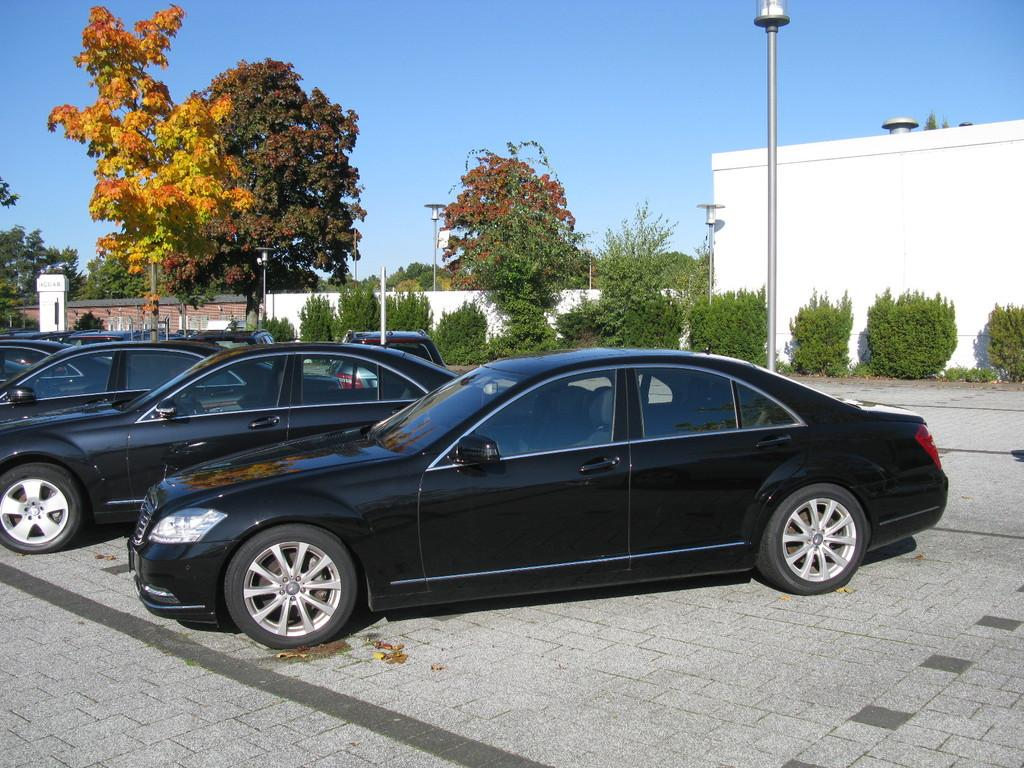What can be seen parked in the image? There are cars parked in the image. What structure is present in the image that provides light? There is a light pole in the image. What type of vegetation is visible in the image? Trees and bushes are present in the image. What type of man-made structure is visible in the image? There is a building wall in the image. What architectural feature can be seen in the image? There is a pillar in the image. What is visible in the sky in the image? The sky is visible in the image. How many friends can be seen interacting with the clam in the image? There are no friends or clams present in the image. What effect does the presence of the pillar have on the building's structural integrity in the image? The provided facts do not give information about the building's structural integrity, so we cannot determine the effect of the pillar on it. 